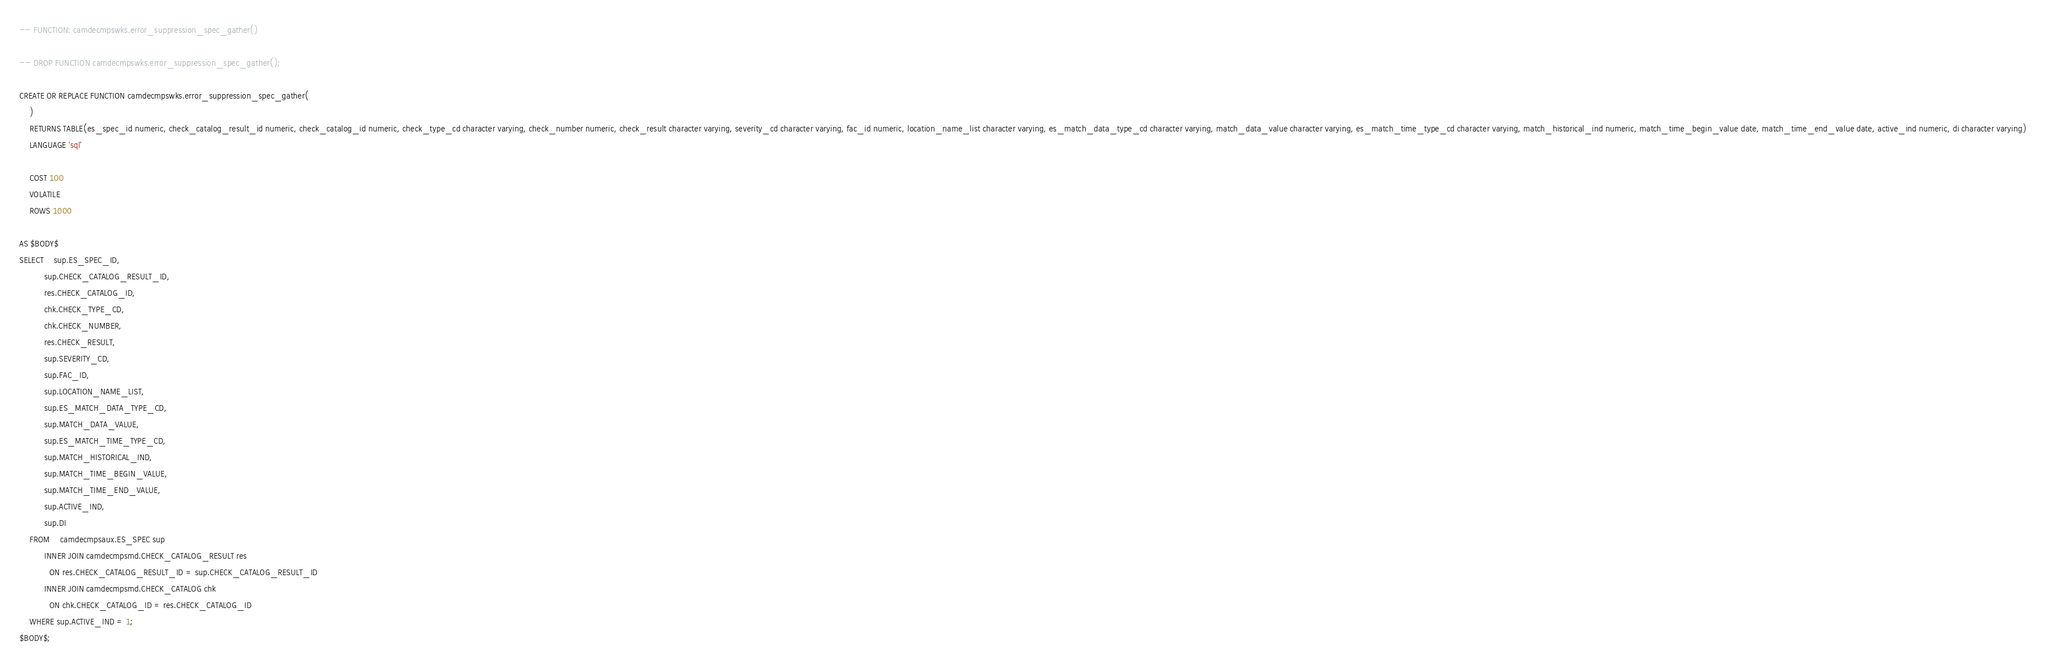Convert code to text. <code><loc_0><loc_0><loc_500><loc_500><_SQL_>-- FUNCTION: camdecmpswks.error_suppression_spec_gather()

-- DROP FUNCTION camdecmpswks.error_suppression_spec_gather();

CREATE OR REPLACE FUNCTION camdecmpswks.error_suppression_spec_gather(
	)
    RETURNS TABLE(es_spec_id numeric, check_catalog_result_id numeric, check_catalog_id numeric, check_type_cd character varying, check_number numeric, check_result character varying, severity_cd character varying, fac_id numeric, location_name_list character varying, es_match_data_type_cd character varying, match_data_value character varying, es_match_time_type_cd character varying, match_historical_ind numeric, match_time_begin_value date, match_time_end_value date, active_ind numeric, di character varying) 
    LANGUAGE 'sql'

    COST 100
    VOLATILE 
    ROWS 1000
    
AS $BODY$
SELECT	sup.ES_SPEC_ID,
          sup.CHECK_CATALOG_RESULT_ID,
          res.CHECK_CATALOG_ID,
          chk.CHECK_TYPE_CD,
          chk.CHECK_NUMBER,
          res.CHECK_RESULT,
          sup.SEVERITY_CD,
          sup.FAC_ID,
          sup.LOCATION_NAME_LIST,
          sup.ES_MATCH_DATA_TYPE_CD,
          sup.MATCH_DATA_VALUE,
          sup.ES_MATCH_TIME_TYPE_CD,
          sup.MATCH_HISTORICAL_IND,
          sup.MATCH_TIME_BEGIN_VALUE,
          sup.MATCH_TIME_END_VALUE,
          sup.ACTIVE_IND,
          sup.DI
    FROM	camdecmpsaux.ES_SPEC sup
          INNER JOIN camdecmpsmd.CHECK_CATALOG_RESULT res 
            ON res.CHECK_CATALOG_RESULT_ID = sup.CHECK_CATALOG_RESULT_ID
          INNER JOIN camdecmpsmd.CHECK_CATALOG chk
            ON chk.CHECK_CATALOG_ID = res.CHECK_CATALOG_ID
    WHERE sup.ACTIVE_IND = 1;
$BODY$;</code> 